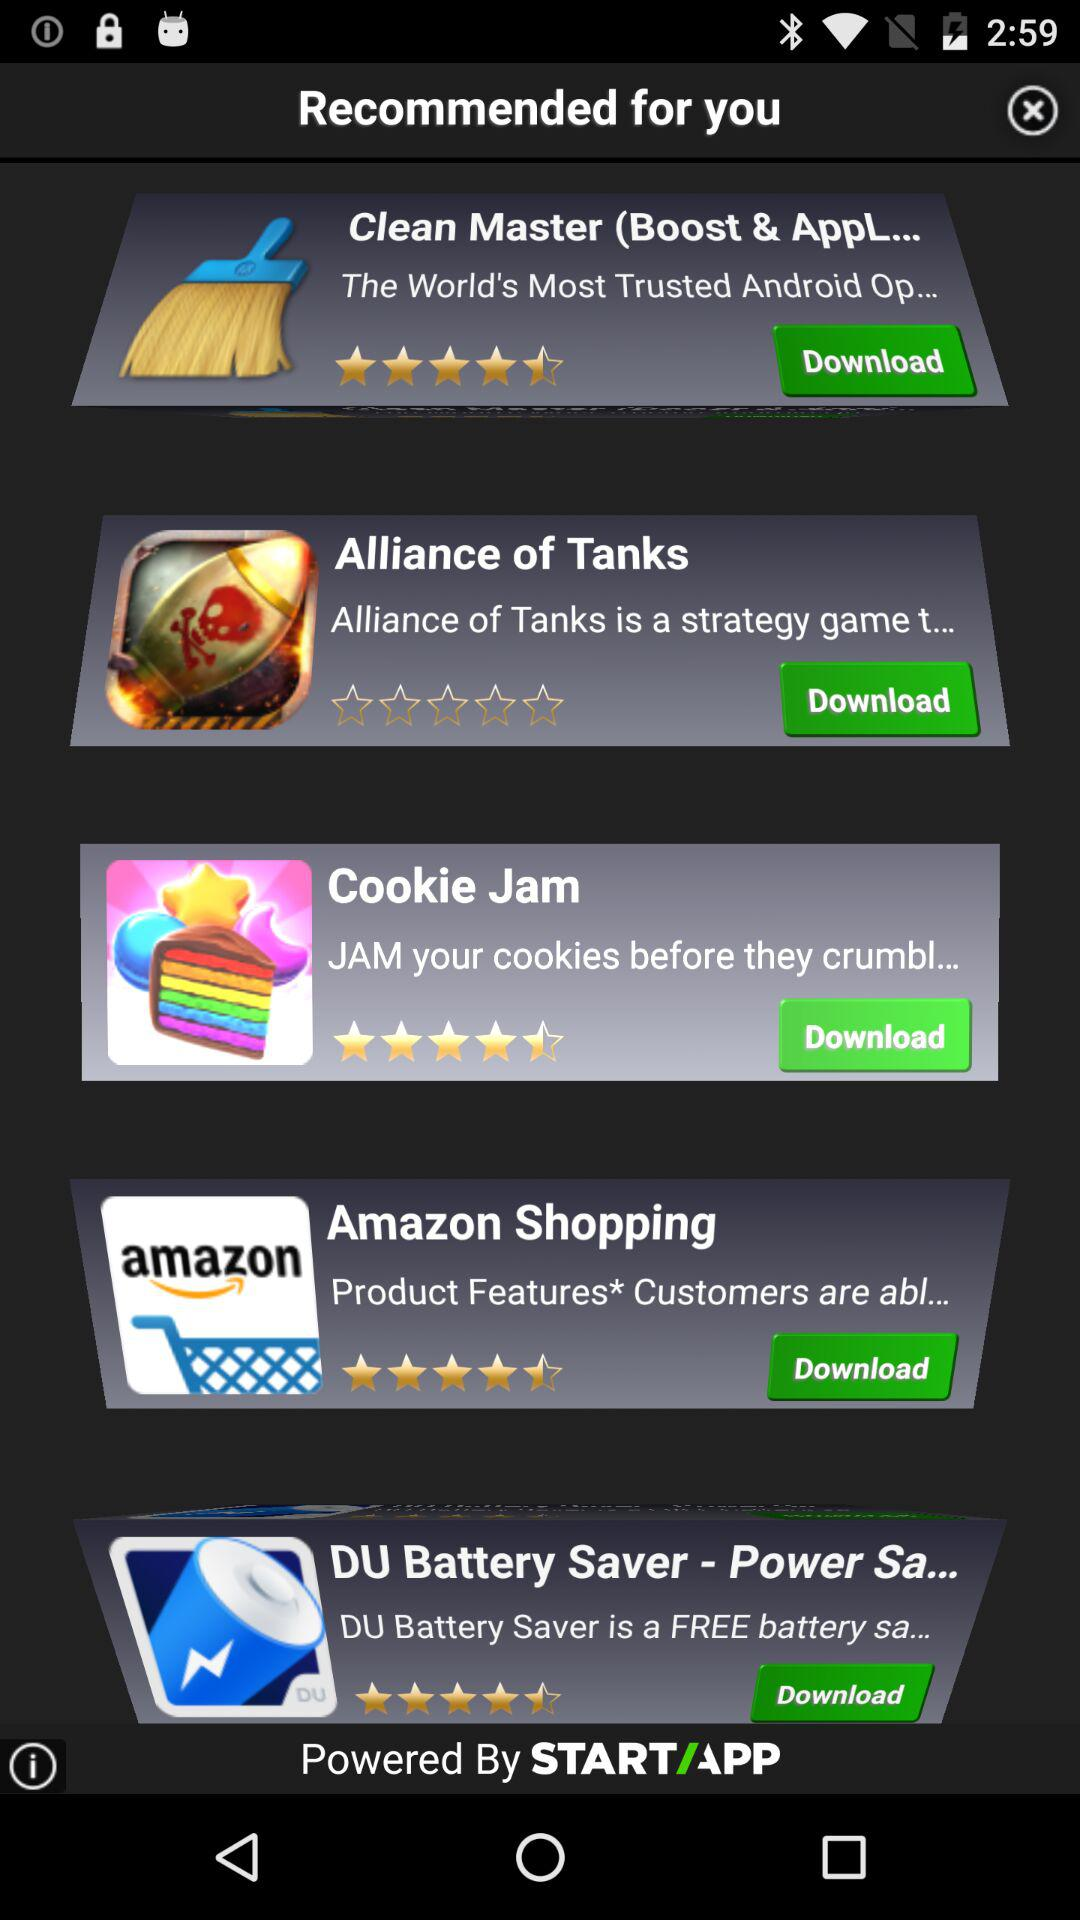What is the rating for "Alliance of Tanks"? "Alliance of Tanks" has a 0 star rating. 